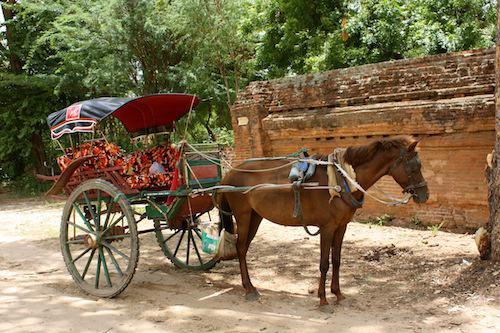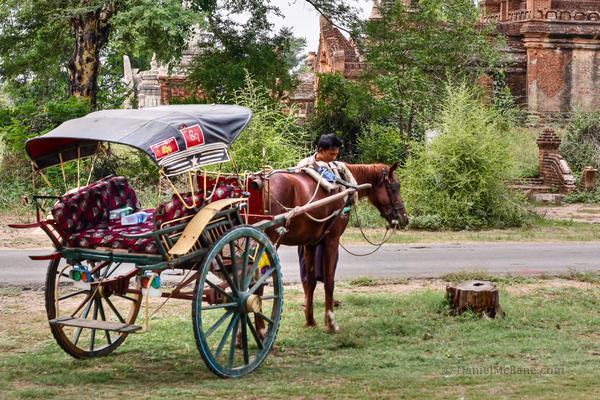The first image is the image on the left, the second image is the image on the right. Assess this claim about the two images: "There is at least one person in the image on the left.". Correct or not? Answer yes or no. No. The first image is the image on the left, the second image is the image on the right. Evaluate the accuracy of this statement regarding the images: "The left image shows a two wheel cart without a person riding in it.". Is it true? Answer yes or no. Yes. 